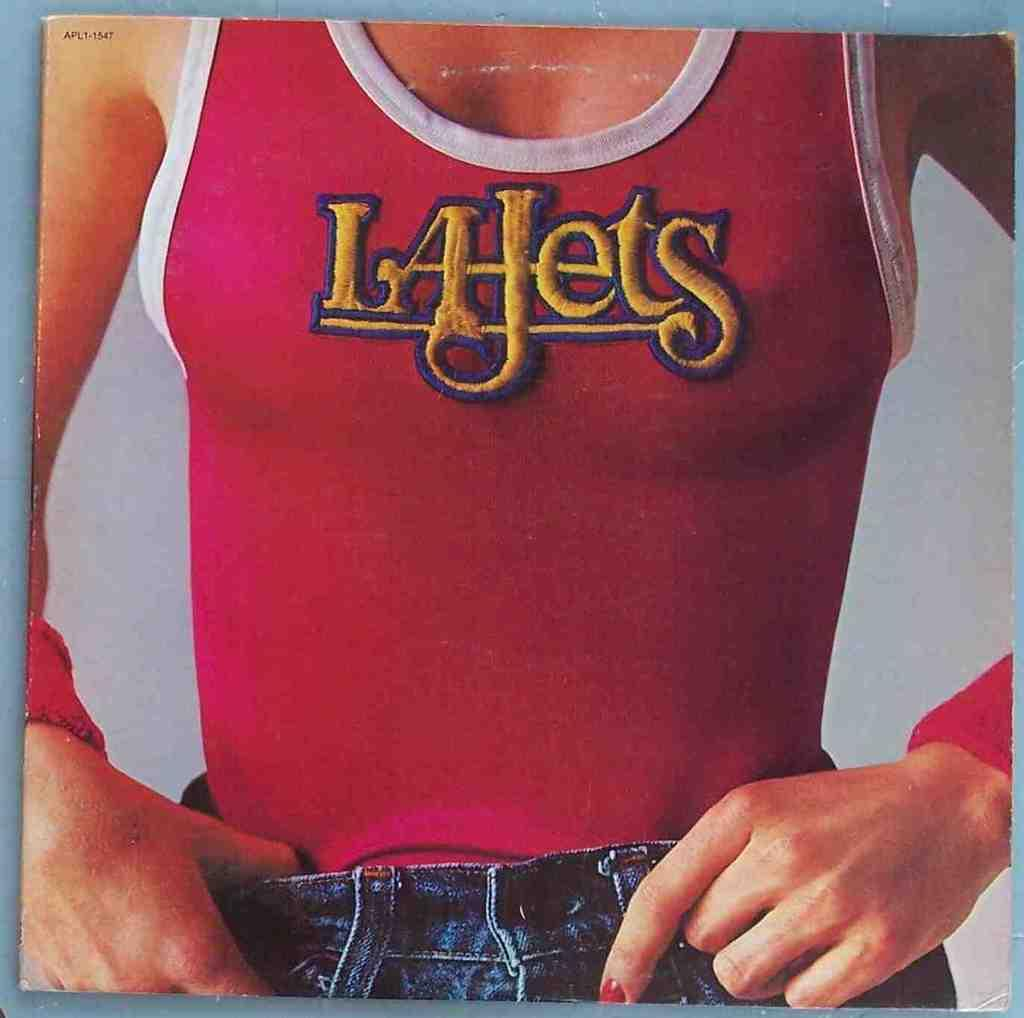<image>
Share a concise interpretation of the image provided. A woman in a tank top that says LA Jets. 